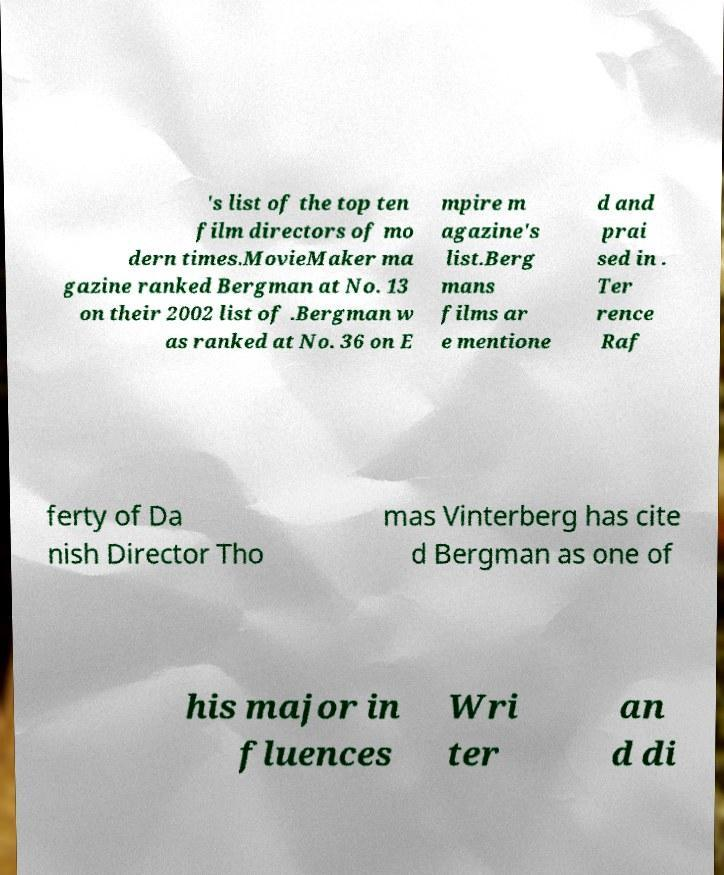Could you extract and type out the text from this image? 's list of the top ten film directors of mo dern times.MovieMaker ma gazine ranked Bergman at No. 13 on their 2002 list of .Bergman w as ranked at No. 36 on E mpire m agazine's list.Berg mans films ar e mentione d and prai sed in . Ter rence Raf ferty of Da nish Director Tho mas Vinterberg has cite d Bergman as one of his major in fluences Wri ter an d di 